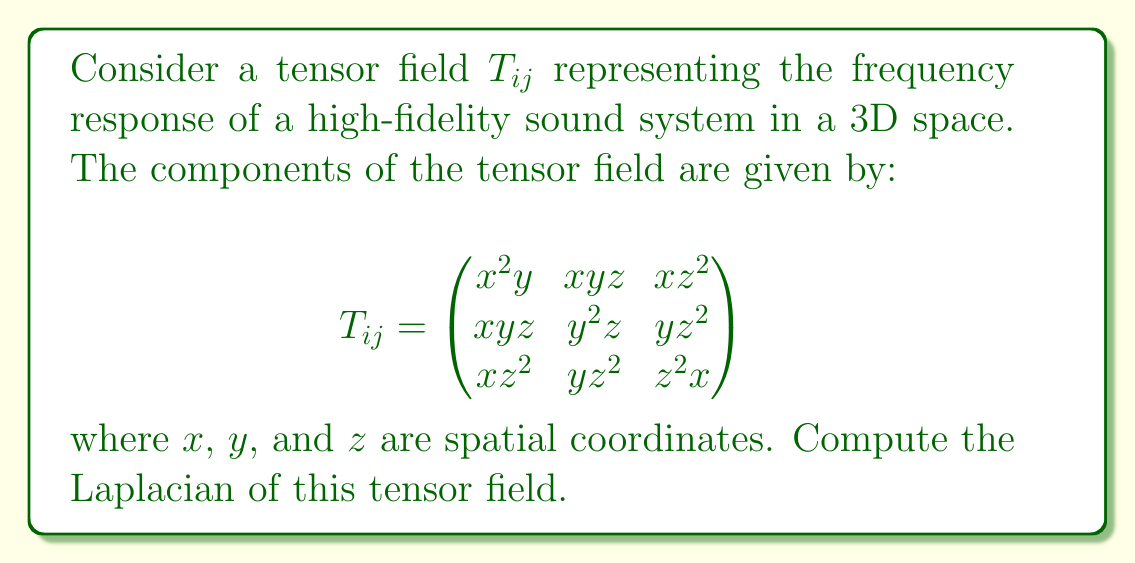Provide a solution to this math problem. To compute the Laplacian of the tensor field, we need to follow these steps:

1) The Laplacian of a tensor field is defined as the sum of the second partial derivatives with respect to each spatial coordinate:

   $$\nabla^2 T_{ij} = \frac{\partial^2 T_{ij}}{\partial x^2} + \frac{\partial^2 T_{ij}}{\partial y^2} + \frac{\partial^2 T_{ij}}{\partial z^2}$$

2) Let's compute the second partial derivatives for each component:

   For $T_{11} = x^2y$:
   $$\frac{\partial^2 T_{11}}{\partial x^2} = 2y, \frac{\partial^2 T_{11}}{\partial y^2} = 0, \frac{\partial^2 T_{11}}{\partial z^2} = 0$$

   For $T_{12} = T_{21} = xyz$:
   $$\frac{\partial^2 T_{12}}{\partial x^2} = 0, \frac{\partial^2 T_{12}}{\partial y^2} = 0, \frac{\partial^2 T_{12}}{\partial z^2} = 0$$

   For $T_{13} = T_{31} = xz^2$:
   $$\frac{\partial^2 T_{13}}{\partial x^2} = 0, \frac{\partial^2 T_{13}}{\partial y^2} = 0, \frac{\partial^2 T_{13}}{\partial z^2} = 2x$$

   For $T_{22} = y^2z$:
   $$\frac{\partial^2 T_{22}}{\partial x^2} = 0, \frac{\partial^2 T_{22}}{\partial y^2} = 2z, \frac{\partial^2 T_{22}}{\partial z^2} = 0$$

   For $T_{23} = T_{32} = yz^2$:
   $$\frac{\partial^2 T_{23}}{\partial x^2} = 0, \frac{\partial^2 T_{23}}{\partial y^2} = 0, \frac{\partial^2 T_{23}}{\partial z^2} = 2y$$

   For $T_{33} = z^2x$:
   $$\frac{\partial^2 T_{33}}{\partial x^2} = 0, \frac{\partial^2 T_{33}}{\partial y^2} = 0, \frac{\partial^2 T_{33}}{\partial z^2} = 2x$$

3) Now, we sum these second partial derivatives for each component:

   $$\nabla^2 T_{ij} = \begin{pmatrix}
   2y & 0 & 2x \\
   0 & 2z & 2y \\
   2x & 2y & 2x
   \end{pmatrix}$$

This is the Laplacian of the tensor field $T_{ij}$.
Answer: $$\nabla^2 T_{ij} = \begin{pmatrix}
2y & 0 & 2x \\
0 & 2z & 2y \\
2x & 2y & 2x
\end{pmatrix}$$ 